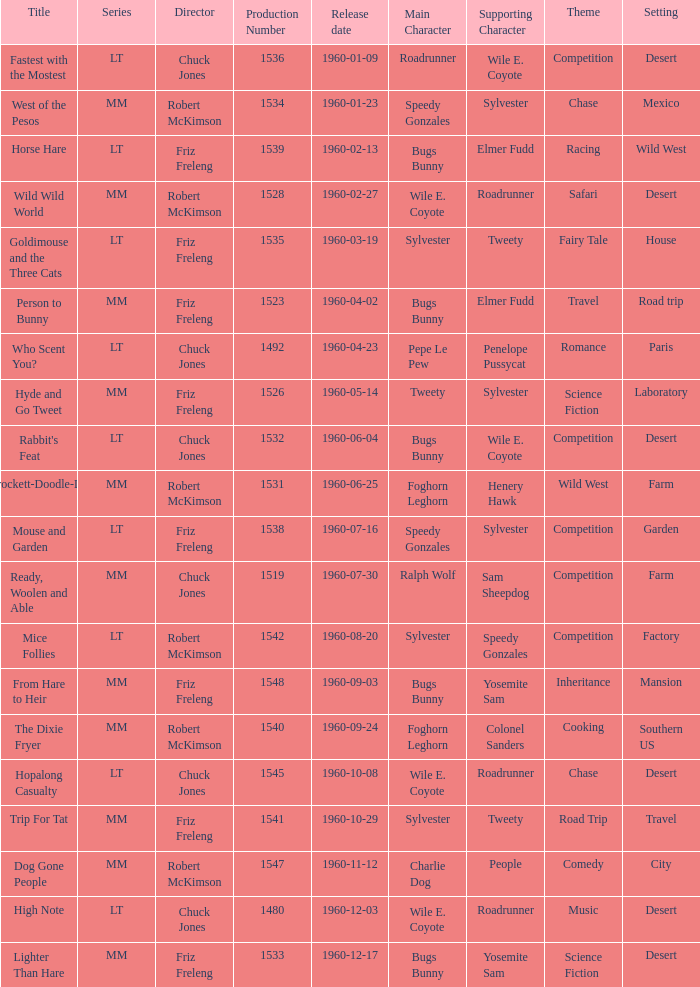What is the production number of From Hare to Heir? 1548.0. 